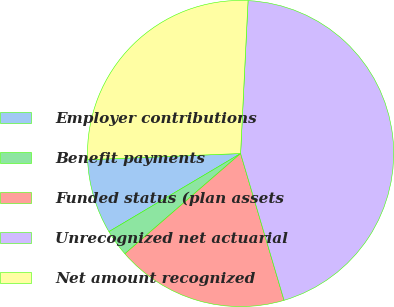<chart> <loc_0><loc_0><loc_500><loc_500><pie_chart><fcel>Employer contributions<fcel>Benefit payments<fcel>Funded status (plan assets<fcel>Unrecognized net actuarial<fcel>Net amount recognized<nl><fcel>7.88%<fcel>2.84%<fcel>18.22%<fcel>44.64%<fcel>26.42%<nl></chart> 